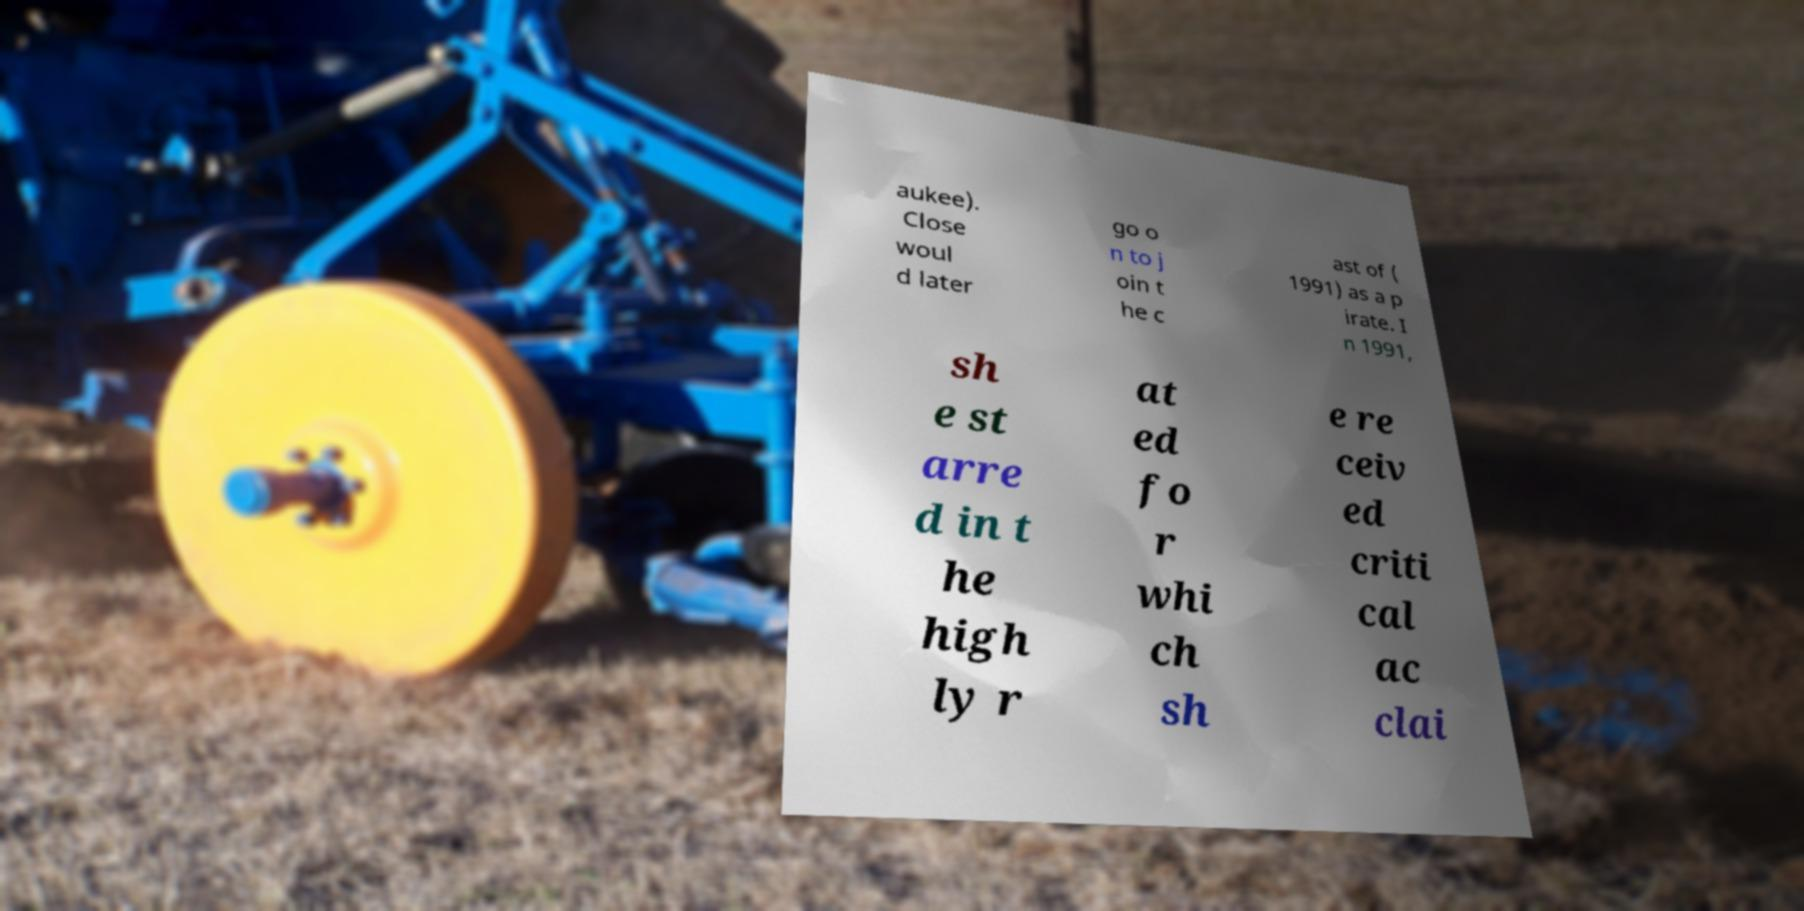There's text embedded in this image that I need extracted. Can you transcribe it verbatim? aukee). Close woul d later go o n to j oin t he c ast of ( 1991) as a p irate. I n 1991, sh e st arre d in t he high ly r at ed fo r whi ch sh e re ceiv ed criti cal ac clai 